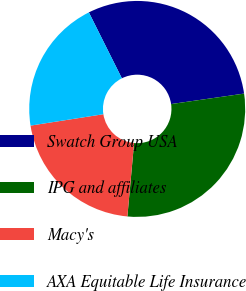Convert chart. <chart><loc_0><loc_0><loc_500><loc_500><pie_chart><fcel>Swatch Group USA<fcel>IPG and affiliates<fcel>Macy's<fcel>AXA Equitable Life Insurance<nl><fcel>30.12%<fcel>28.72%<fcel>21.08%<fcel>20.08%<nl></chart> 